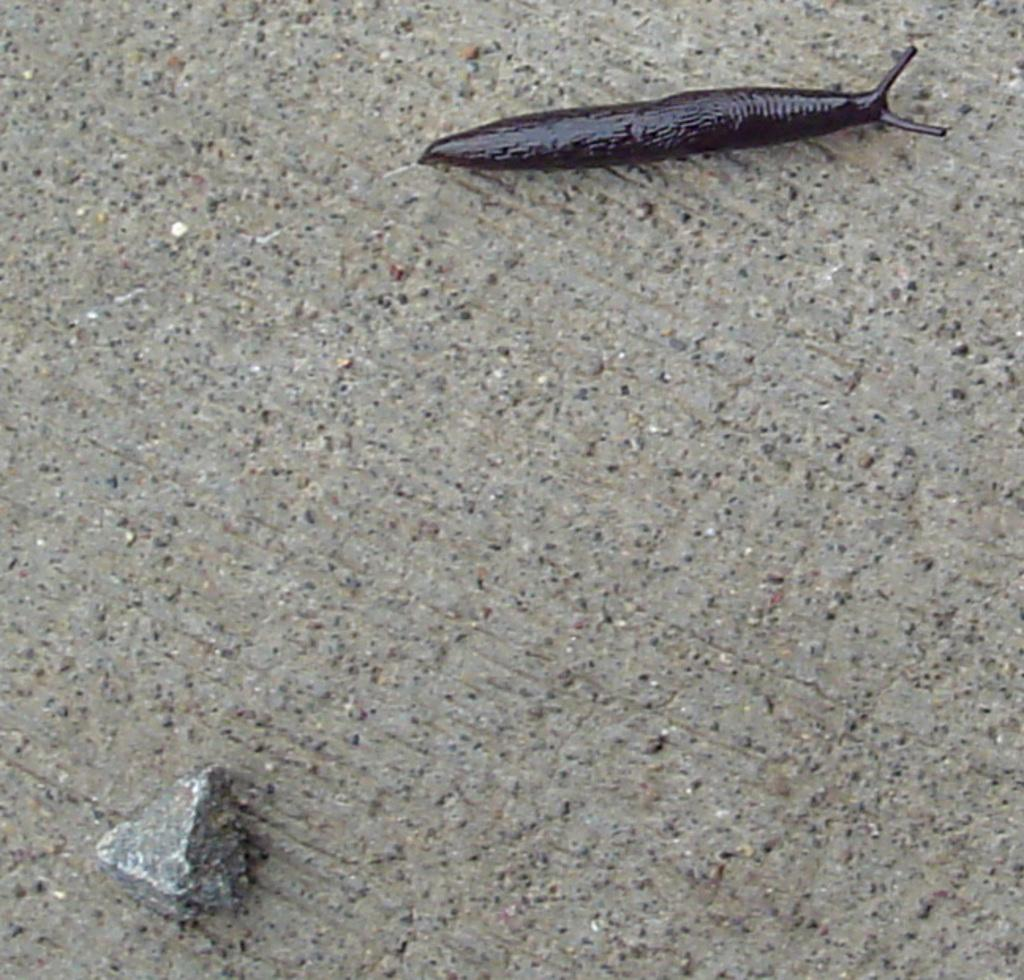What type of animal can be seen in the picture? There is a slug in the picture. What object is present on the floor in the picture? There is a stone on the floor in the picture. How many mice are running around the airport in the image? There are no mice or airports present in the image; it features a slug and a stone. What color are the toes of the person in the image? There is no person present in the image, so there are no toes to describe. 